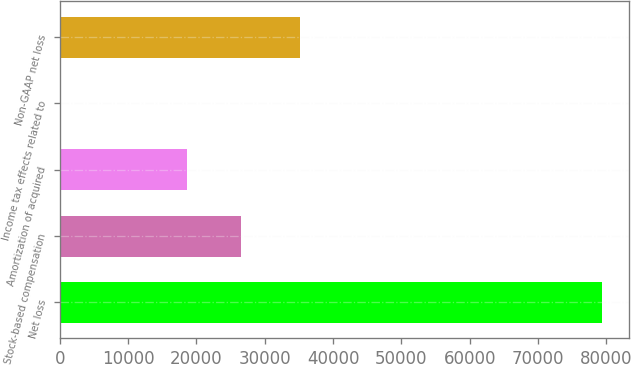Convert chart to OTSL. <chart><loc_0><loc_0><loc_500><loc_500><bar_chart><fcel>Net loss<fcel>Stock-based compensation<fcel>Amortization of acquired<fcel>Income tax effects related to<fcel>Non-GAAP net loss<nl><fcel>79399<fcel>26604.9<fcel>18687<fcel>220<fcel>35191<nl></chart> 